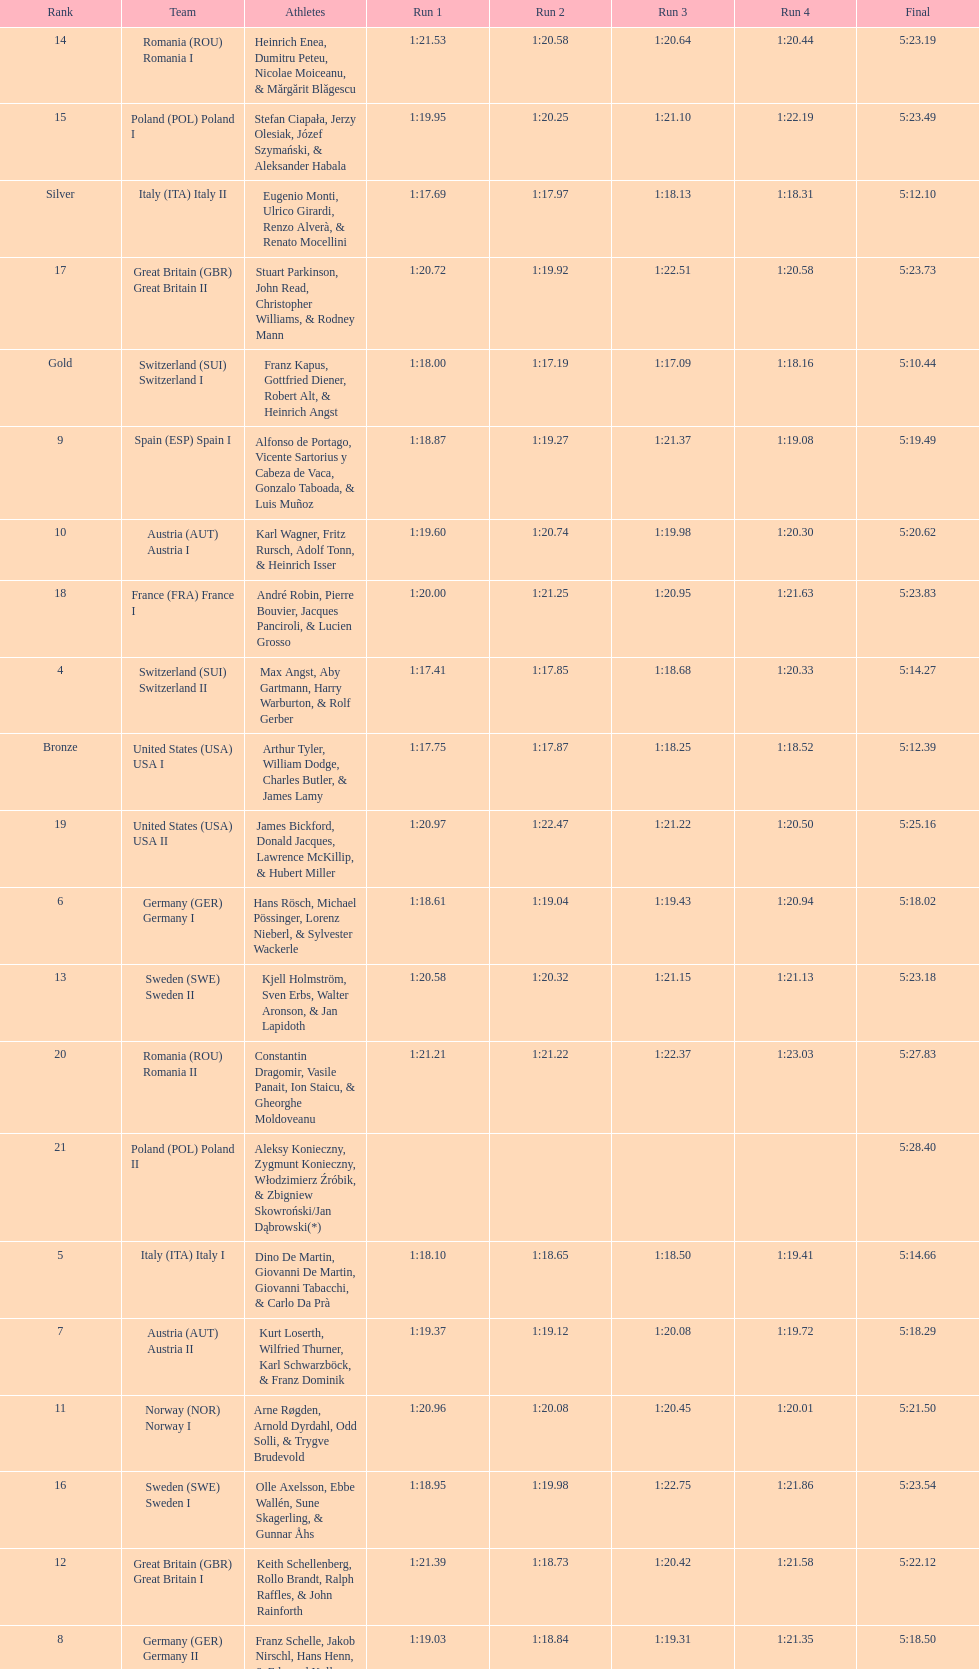Parse the table in full. {'header': ['Rank', 'Team', 'Athletes', 'Run 1', 'Run 2', 'Run 3', 'Run 4', 'Final'], 'rows': [['14', 'Romania\xa0(ROU) Romania I', 'Heinrich Enea, Dumitru Peteu, Nicolae Moiceanu, & Mărgărit Blăgescu', '1:21.53', '1:20.58', '1:20.64', '1:20.44', '5:23.19'], ['15', 'Poland\xa0(POL) Poland I', 'Stefan Ciapała, Jerzy Olesiak, Józef Szymański, & Aleksander Habala', '1:19.95', '1:20.25', '1:21.10', '1:22.19', '5:23.49'], ['Silver', 'Italy\xa0(ITA) Italy II', 'Eugenio Monti, Ulrico Girardi, Renzo Alverà, & Renato Mocellini', '1:17.69', '1:17.97', '1:18.13', '1:18.31', '5:12.10'], ['17', 'Great Britain\xa0(GBR) Great Britain II', 'Stuart Parkinson, John Read, Christopher Williams, & Rodney Mann', '1:20.72', '1:19.92', '1:22.51', '1:20.58', '5:23.73'], ['Gold', 'Switzerland\xa0(SUI) Switzerland I', 'Franz Kapus, Gottfried Diener, Robert Alt, & Heinrich Angst', '1:18.00', '1:17.19', '1:17.09', '1:18.16', '5:10.44'], ['9', 'Spain\xa0(ESP) Spain I', 'Alfonso de Portago, Vicente Sartorius y Cabeza de Vaca, Gonzalo Taboada, & Luis Muñoz', '1:18.87', '1:19.27', '1:21.37', '1:19.08', '5:19.49'], ['10', 'Austria\xa0(AUT) Austria I', 'Karl Wagner, Fritz Rursch, Adolf Tonn, & Heinrich Isser', '1:19.60', '1:20.74', '1:19.98', '1:20.30', '5:20.62'], ['18', 'France\xa0(FRA) France I', 'André Robin, Pierre Bouvier, Jacques Panciroli, & Lucien Grosso', '1:20.00', '1:21.25', '1:20.95', '1:21.63', '5:23.83'], ['4', 'Switzerland\xa0(SUI) Switzerland II', 'Max Angst, Aby Gartmann, Harry Warburton, & Rolf Gerber', '1:17.41', '1:17.85', '1:18.68', '1:20.33', '5:14.27'], ['Bronze', 'United States\xa0(USA) USA I', 'Arthur Tyler, William Dodge, Charles Butler, & James Lamy', '1:17.75', '1:17.87', '1:18.25', '1:18.52', '5:12.39'], ['19', 'United States\xa0(USA) USA II', 'James Bickford, Donald Jacques, Lawrence McKillip, & Hubert Miller', '1:20.97', '1:22.47', '1:21.22', '1:20.50', '5:25.16'], ['6', 'Germany\xa0(GER) Germany I', 'Hans Rösch, Michael Pössinger, Lorenz Nieberl, & Sylvester Wackerle', '1:18.61', '1:19.04', '1:19.43', '1:20.94', '5:18.02'], ['13', 'Sweden\xa0(SWE) Sweden II', 'Kjell Holmström, Sven Erbs, Walter Aronson, & Jan Lapidoth', '1:20.58', '1:20.32', '1:21.15', '1:21.13', '5:23.18'], ['20', 'Romania\xa0(ROU) Romania II', 'Constantin Dragomir, Vasile Panait, Ion Staicu, & Gheorghe Moldoveanu', '1:21.21', '1:21.22', '1:22.37', '1:23.03', '5:27.83'], ['21', 'Poland\xa0(POL) Poland II', 'Aleksy Konieczny, Zygmunt Konieczny, Włodzimierz Źróbik, & Zbigniew Skowroński/Jan Dąbrowski(*)', '', '', '', '', '5:28.40'], ['5', 'Italy\xa0(ITA) Italy I', 'Dino De Martin, Giovanni De Martin, Giovanni Tabacchi, & Carlo Da Prà', '1:18.10', '1:18.65', '1:18.50', '1:19.41', '5:14.66'], ['7', 'Austria\xa0(AUT) Austria II', 'Kurt Loserth, Wilfried Thurner, Karl Schwarzböck, & Franz Dominik', '1:19.37', '1:19.12', '1:20.08', '1:19.72', '5:18.29'], ['11', 'Norway\xa0(NOR) Norway I', 'Arne Røgden, Arnold Dyrdahl, Odd Solli, & Trygve Brudevold', '1:20.96', '1:20.08', '1:20.45', '1:20.01', '5:21.50'], ['16', 'Sweden\xa0(SWE) Sweden I', 'Olle Axelsson, Ebbe Wallén, Sune Skagerling, & Gunnar Åhs', '1:18.95', '1:19.98', '1:22.75', '1:21.86', '5:23.54'], ['12', 'Great Britain\xa0(GBR) Great Britain I', 'Keith Schellenberg, Rollo Brandt, Ralph Raffles, & John Rainforth', '1:21.39', '1:18.73', '1:20.42', '1:21.58', '5:22.12'], ['8', 'Germany\xa0(GER) Germany II', 'Franz Schelle, Jakob Nirschl, Hans Henn, & Edmund Koller', '1:19.03', '1:18.84', '1:19.31', '1:21.35', '5:18.50']]} What team came in second to last place? Romania. 